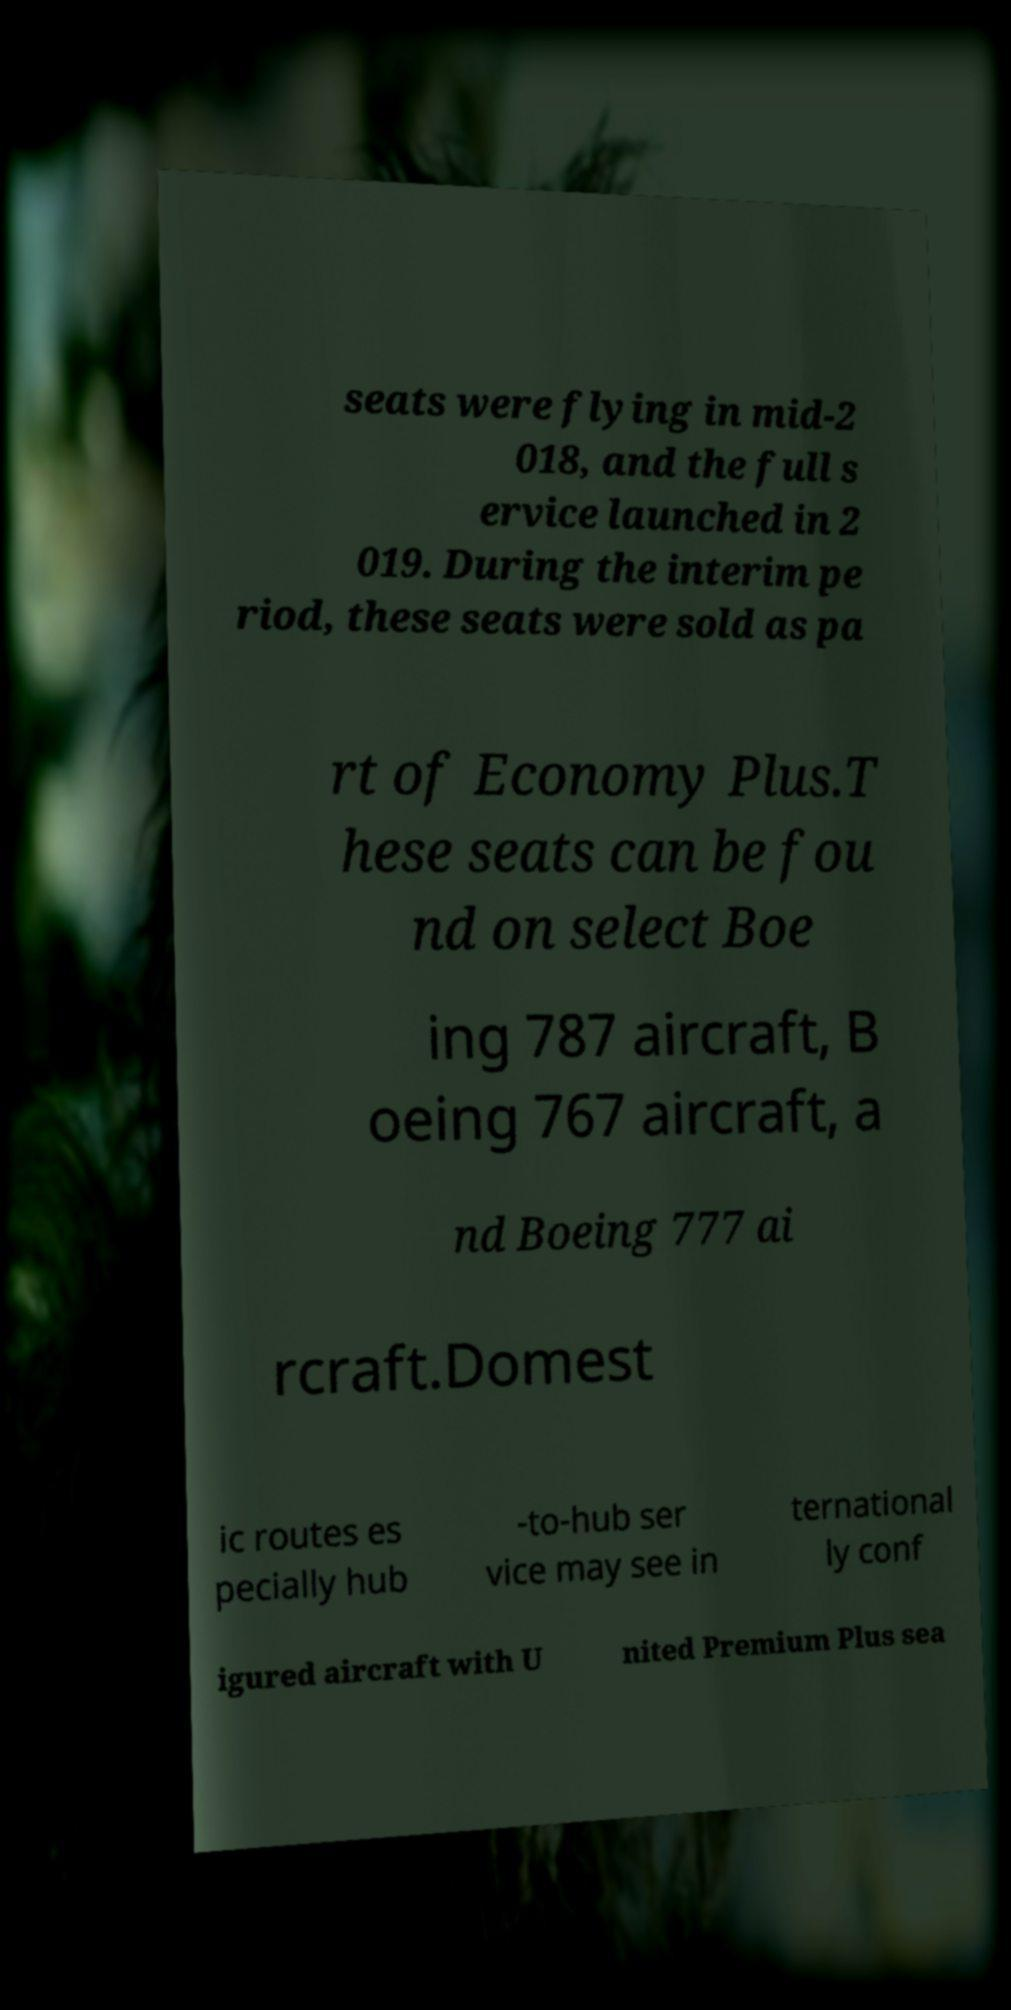What messages or text are displayed in this image? I need them in a readable, typed format. seats were flying in mid-2 018, and the full s ervice launched in 2 019. During the interim pe riod, these seats were sold as pa rt of Economy Plus.T hese seats can be fou nd on select Boe ing 787 aircraft, B oeing 767 aircraft, a nd Boeing 777 ai rcraft.Domest ic routes es pecially hub -to-hub ser vice may see in ternational ly conf igured aircraft with U nited Premium Plus sea 